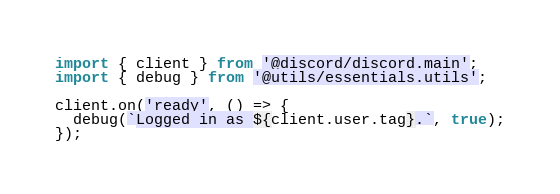<code> <loc_0><loc_0><loc_500><loc_500><_TypeScript_>import { client } from '@discord/discord.main';
import { debug } from '@utils/essentials.utils';

client.on('ready', () => {
  debug(`Logged in as ${client.user.tag}.`, true);
});
</code> 